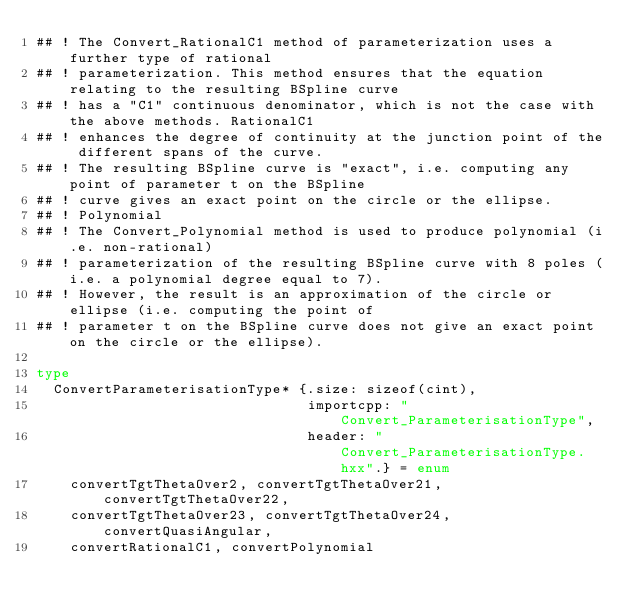Convert code to text. <code><loc_0><loc_0><loc_500><loc_500><_Nim_>## ! The Convert_RationalC1 method of parameterization uses a further type of rational
## ! parameterization. This method ensures that the equation relating to the resulting BSpline curve
## ! has a "C1" continuous denominator, which is not the case with the above methods. RationalC1
## ! enhances the degree of continuity at the junction point of the different spans of the curve.
## ! The resulting BSpline curve is "exact", i.e. computing any point of parameter t on the BSpline
## ! curve gives an exact point on the circle or the ellipse.
## ! Polynomial
## ! The Convert_Polynomial method is used to produce polynomial (i.e. non-rational)
## ! parameterization of the resulting BSpline curve with 8 poles (i.e. a polynomial degree equal to 7).
## ! However, the result is an approximation of the circle or ellipse (i.e. computing the point of
## ! parameter t on the BSpline curve does not give an exact point on the circle or the ellipse).

type
  ConvertParameterisationType* {.size: sizeof(cint),
                                importcpp: "Convert_ParameterisationType",
                                header: "Convert_ParameterisationType.hxx".} = enum
    convertTgtThetaOver2, convertTgtThetaOver21, convertTgtThetaOver22,
    convertTgtThetaOver23, convertTgtThetaOver24, convertQuasiAngular,
    convertRationalC1, convertPolynomial

</code> 